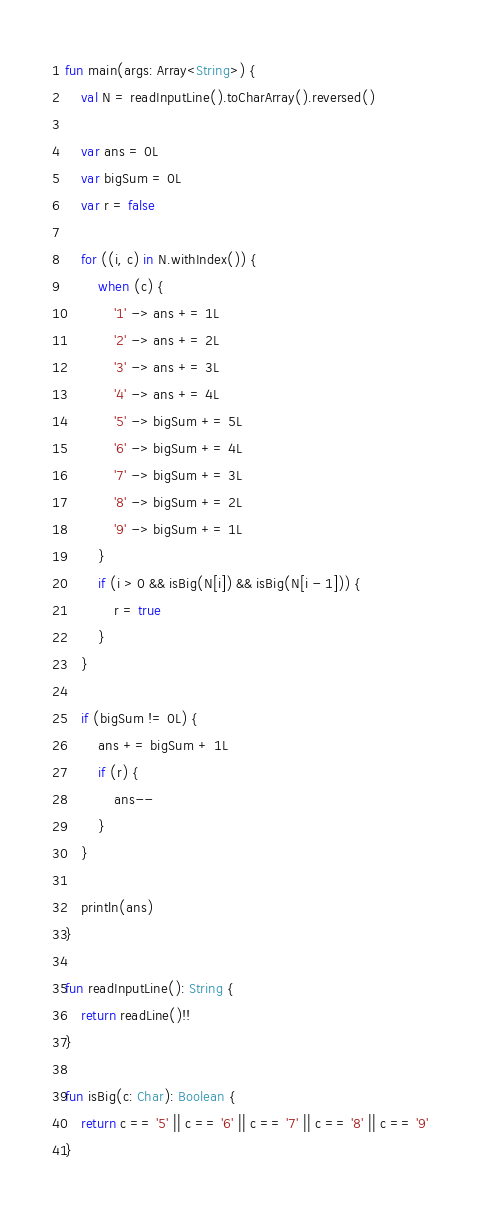Convert code to text. <code><loc_0><loc_0><loc_500><loc_500><_Kotlin_>fun main(args: Array<String>) {
    val N = readInputLine().toCharArray().reversed()

    var ans = 0L
    var bigSum = 0L
    var r = false

    for ((i, c) in N.withIndex()) {
        when (c) {
            '1' -> ans += 1L
            '2' -> ans += 2L
            '3' -> ans += 3L
            '4' -> ans += 4L
            '5' -> bigSum += 5L
            '6' -> bigSum += 4L
            '7' -> bigSum += 3L
            '8' -> bigSum += 2L
            '9' -> bigSum += 1L
        }
        if (i > 0 && isBig(N[i]) && isBig(N[i - 1])) {
            r = true
        }
    }

    if (bigSum != 0L) {
        ans += bigSum + 1L
        if (r) {
            ans--
        }
    }

    println(ans)
}

fun readInputLine(): String {
    return readLine()!!
}

fun isBig(c: Char): Boolean {
    return c == '5' || c == '6' || c == '7' || c == '8' || c == '9'
}
</code> 